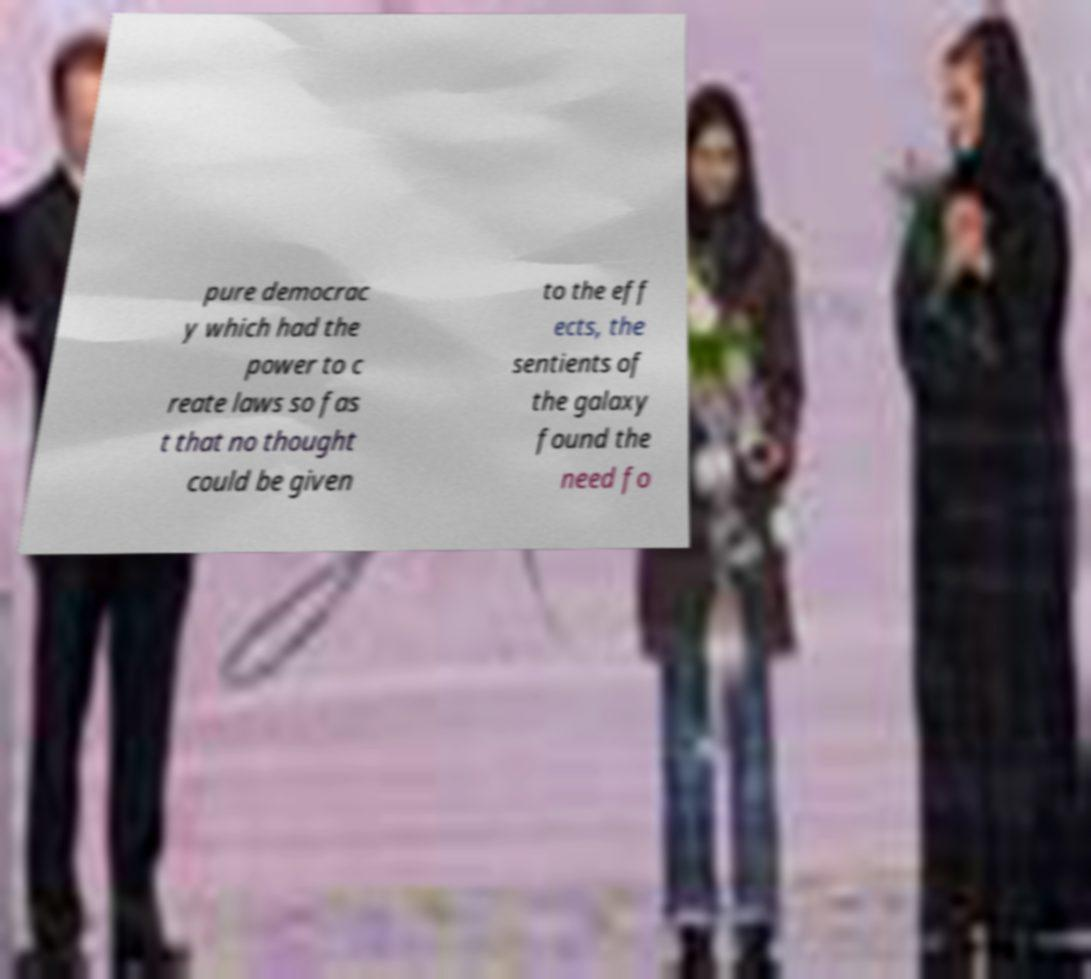Please read and relay the text visible in this image. What does it say? pure democrac y which had the power to c reate laws so fas t that no thought could be given to the eff ects, the sentients of the galaxy found the need fo 